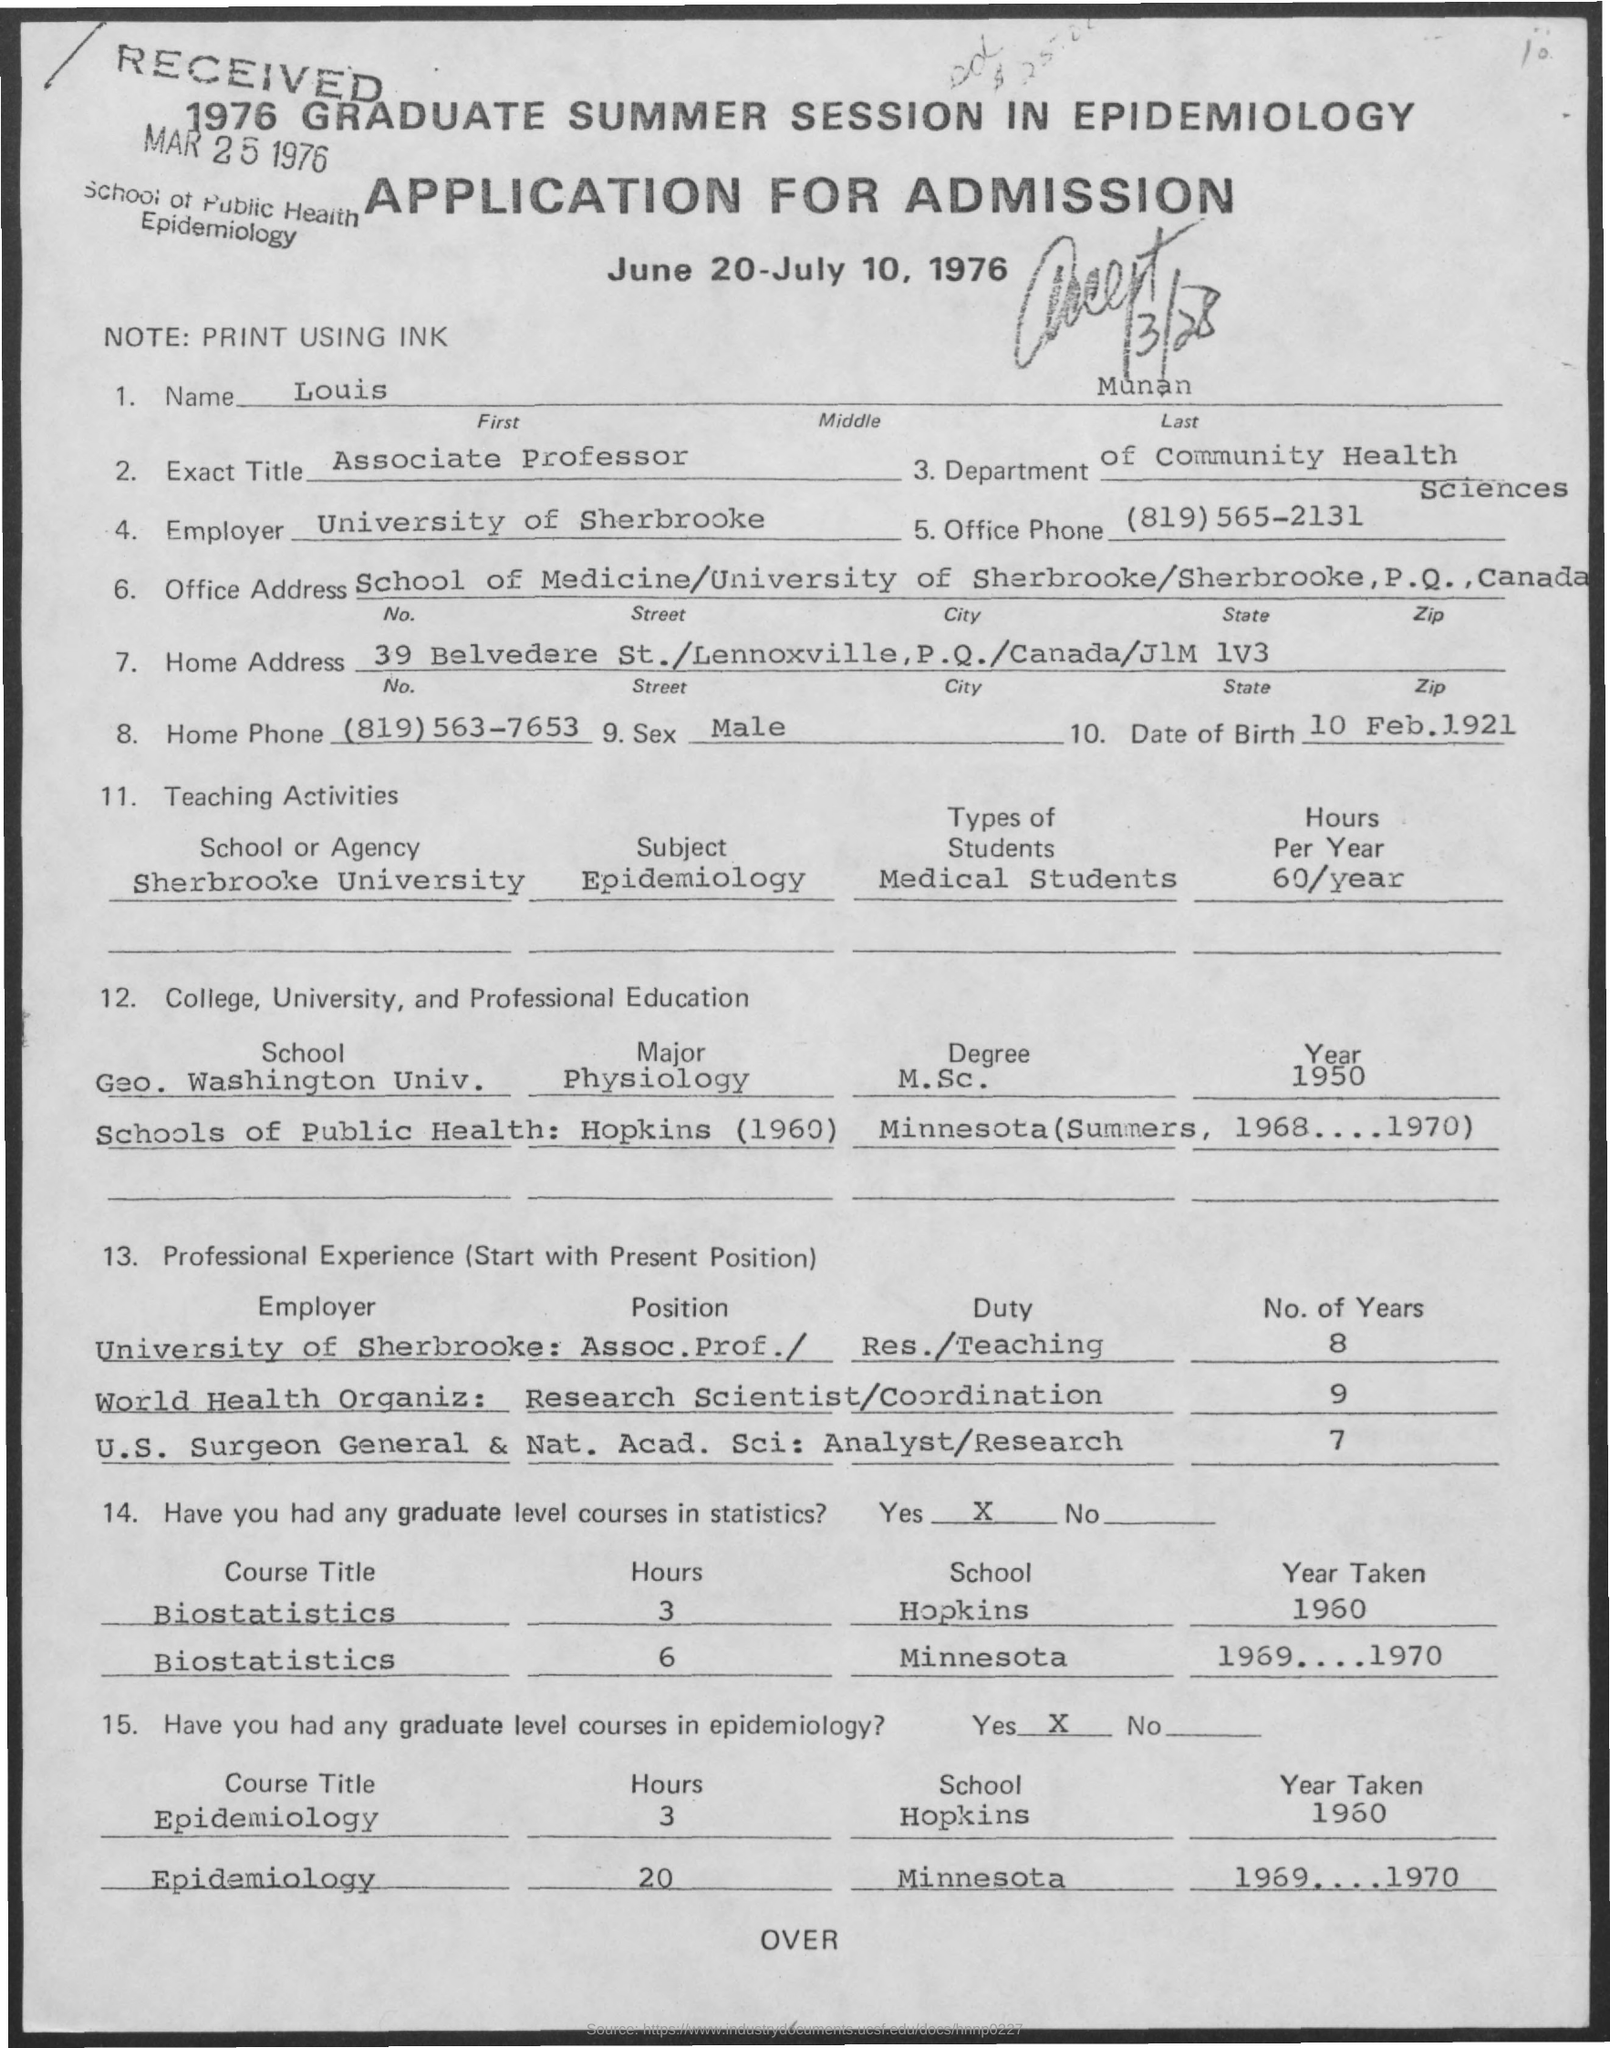In which department, Louis Munan works?
Your response must be concise. Department of Community Health Sciences. Who is the current employer of Louis Munan?
Offer a terse response. University of Sherbrooke. What is the exact title of Louis Munan?
Your answer should be very brief. Associate Professor. What is the date of birth of Louis Munan?
Offer a very short reply. 10 Feb. 1921. When did Louis Munan completed M.Sc. degree in Physiology from Geo. Wahington Univ.?
Your response must be concise. 1950. What was the duty assigned to Louis Munan as a Research Scientist in World Health Organiz:?
Provide a succinct answer. Coordination. 